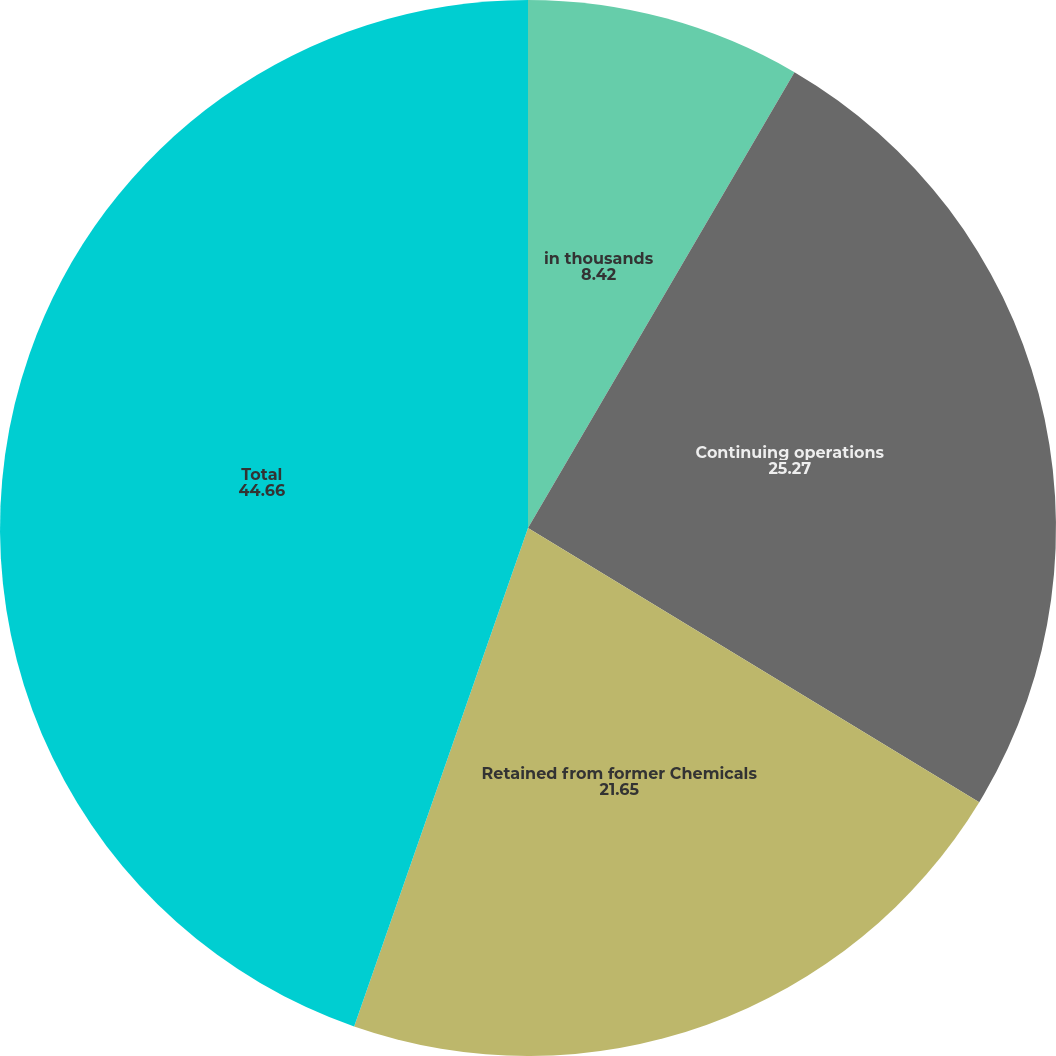Convert chart to OTSL. <chart><loc_0><loc_0><loc_500><loc_500><pie_chart><fcel>in thousands<fcel>Continuing operations<fcel>Retained from former Chemicals<fcel>Total<nl><fcel>8.42%<fcel>25.27%<fcel>21.65%<fcel>44.66%<nl></chart> 